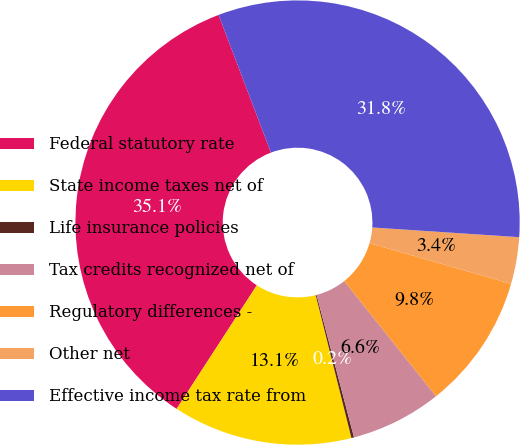Convert chart to OTSL. <chart><loc_0><loc_0><loc_500><loc_500><pie_chart><fcel>Federal statutory rate<fcel>State income taxes net of<fcel>Life insurance policies<fcel>Tax credits recognized net of<fcel>Regulatory differences -<fcel>Other net<fcel>Effective income tax rate from<nl><fcel>35.05%<fcel>13.06%<fcel>0.19%<fcel>6.62%<fcel>9.84%<fcel>3.4%<fcel>31.83%<nl></chart> 